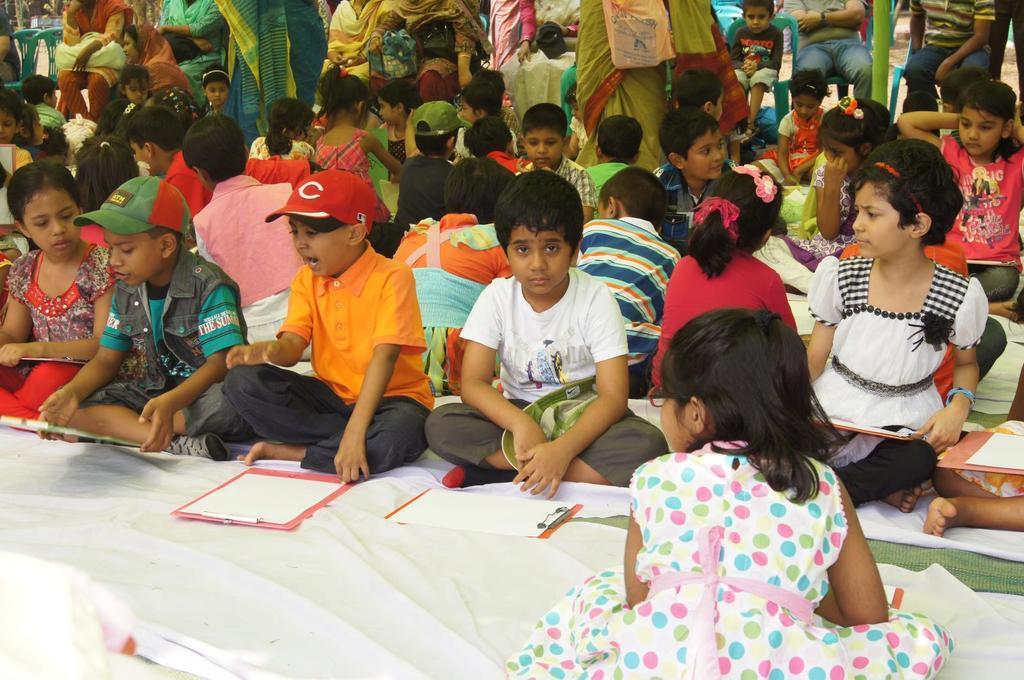Could you give a brief overview of what you see in this image? In this image there are few children seated on the floor, in front of the children there are papers on the writing pad, behind the children there are a few women standing. 